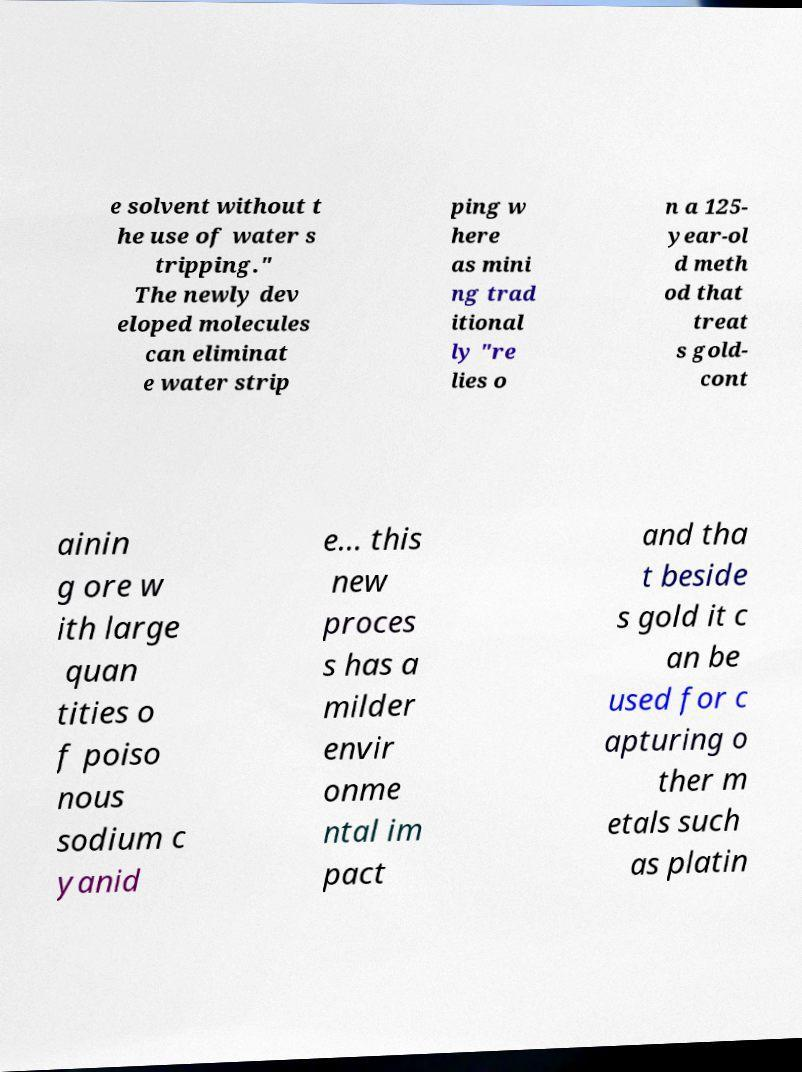Could you extract and type out the text from this image? e solvent without t he use of water s tripping." The newly dev eloped molecules can eliminat e water strip ping w here as mini ng trad itional ly "re lies o n a 125- year-ol d meth od that treat s gold- cont ainin g ore w ith large quan tities o f poiso nous sodium c yanid e... this new proces s has a milder envir onme ntal im pact and tha t beside s gold it c an be used for c apturing o ther m etals such as platin 